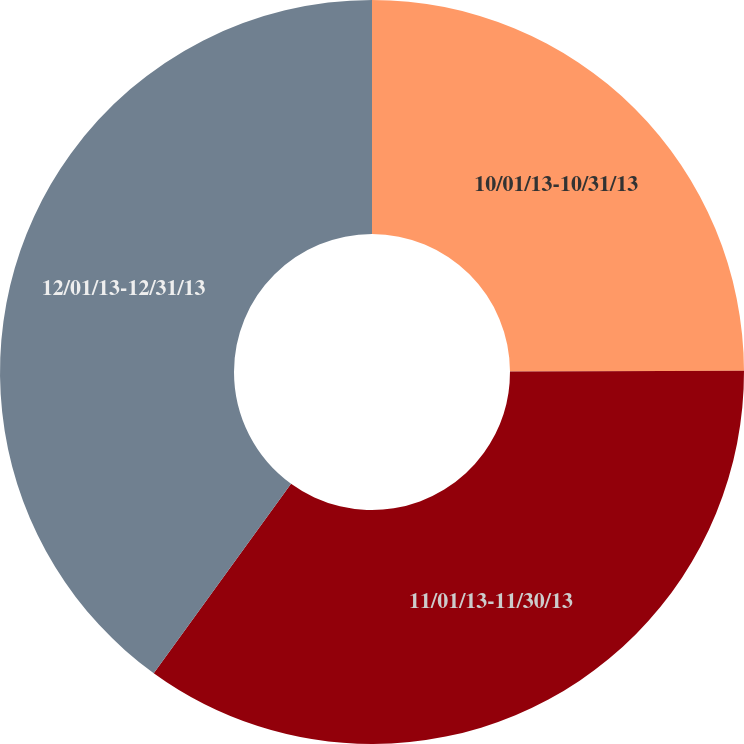Convert chart. <chart><loc_0><loc_0><loc_500><loc_500><pie_chart><fcel>10/01/13-10/31/13<fcel>11/01/13-11/30/13<fcel>12/01/13-12/31/13<nl><fcel>24.95%<fcel>35.03%<fcel>40.02%<nl></chart> 